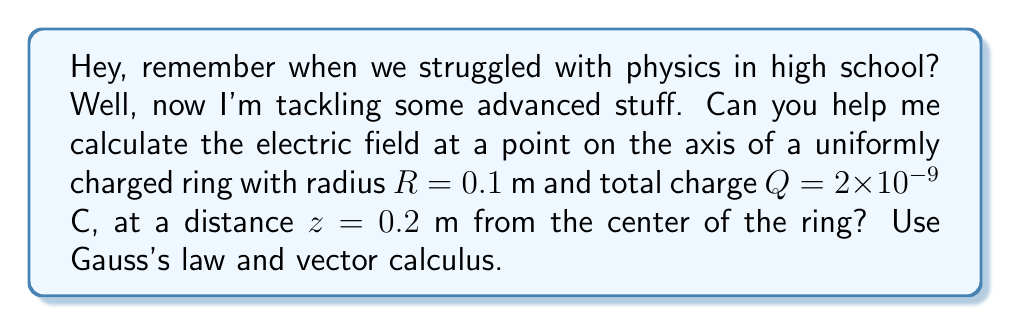Can you answer this question? Let's approach this step-by-step:

1) First, let's visualize the problem:

[asy]
import graph3;
size(200);
currentprojection=perspective(6,3,2);
draw(Circle(O,1,Z),blue);
dot(Label("P",1),(0,0,2)),red);
draw((0,0,0)--(0,0,2),dashed);
label("R",(0.5,0,0),E);
label("z",(0,0,1),W);
[/asy]

2) Due to symmetry, the electric field will only have a component along the z-axis. We can use Gauss's law in its integral form:

   $$\oint \vec{E} \cdot d\vec{A} = \frac{Q_{enc}}{\epsilon_0}$$

3) Choose a Gaussian surface as a sphere centered at the point P. The electric field is constant on this surface due to symmetry.

4) The flux through this sphere is:

   $$\Phi_E = E(2\pi r^2)$$

   where $r$ is the radius of the sphere.

5) The enclosed charge is zero, so Gauss's law gives:

   $$E(2\pi r^2) = 0$$

6) This doesn't give us the magnitude of E, but confirms it's the same at all points on the sphere.

7) To find E, we need to use the principle of superposition. Consider a small element of the ring $dq$. Its contribution to the electric field at P is:

   $$d\vec{E} = \frac{1}{4\pi\epsilon_0} \frac{dq}{(R^2 + z^2)} \hat{r}$$

8) The z-component of this field is:

   $$dE_z = \frac{1}{4\pi\epsilon_0} \frac{dq}{(R^2 + z^2)^{3/2}} z$$

9) Integrating over the entire ring:

   $$E_z = \frac{1}{4\pi\epsilon_0} \frac{z}{(R^2 + z^2)^{3/2}} \int dq = \frac{1}{4\pi\epsilon_0} \frac{Qz}{(R^2 + z^2)^{3/2}}$$

10) Plugging in the values:

    $$E_z = \frac{1}{4\pi(8.85 \times 10^{-12})} \frac{(2 \times 10^{-9})(0.2)}{((0.1)^2 + (0.2)^2)^{3/2}} = 143.2 \text{ N/C}$$
Answer: $E_z = 143.2 \text{ N/C}$ 